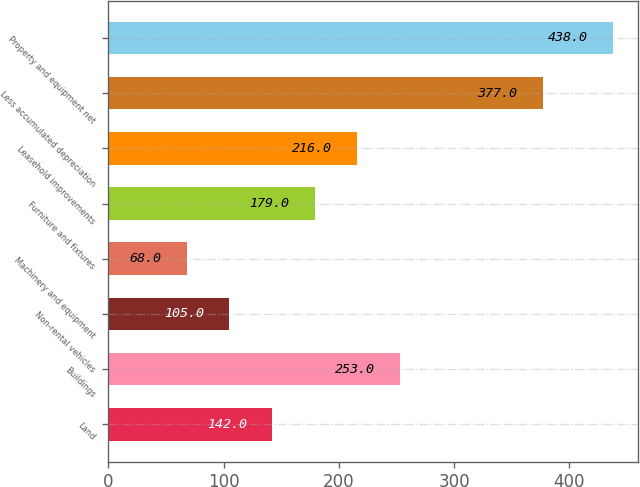Convert chart to OTSL. <chart><loc_0><loc_0><loc_500><loc_500><bar_chart><fcel>Land<fcel>Buildings<fcel>Non-rental vehicles<fcel>Machinery and equipment<fcel>Furniture and fixtures<fcel>Leasehold improvements<fcel>Less accumulated depreciation<fcel>Property and equipment net<nl><fcel>142<fcel>253<fcel>105<fcel>68<fcel>179<fcel>216<fcel>377<fcel>438<nl></chart> 